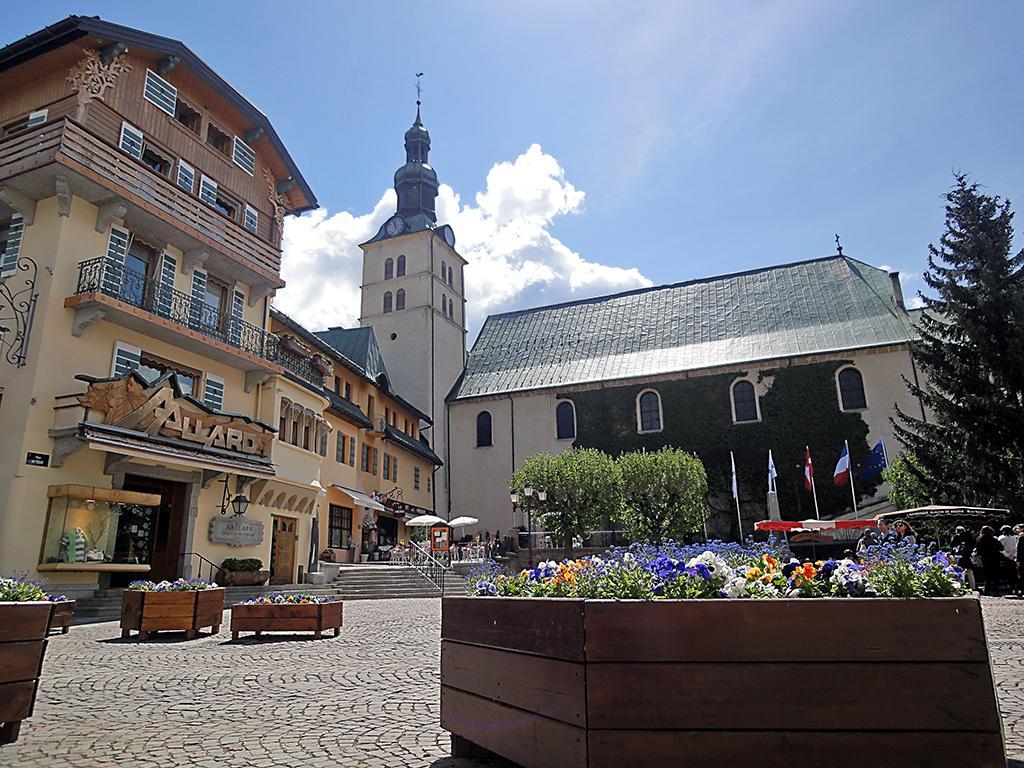Describe this image in one or two sentences. In this picture we can see flower plants on some wooden objects. Behind the wooden objects there are some people standing on the path, trees, poles with lights and flags, buildings and a sky. 